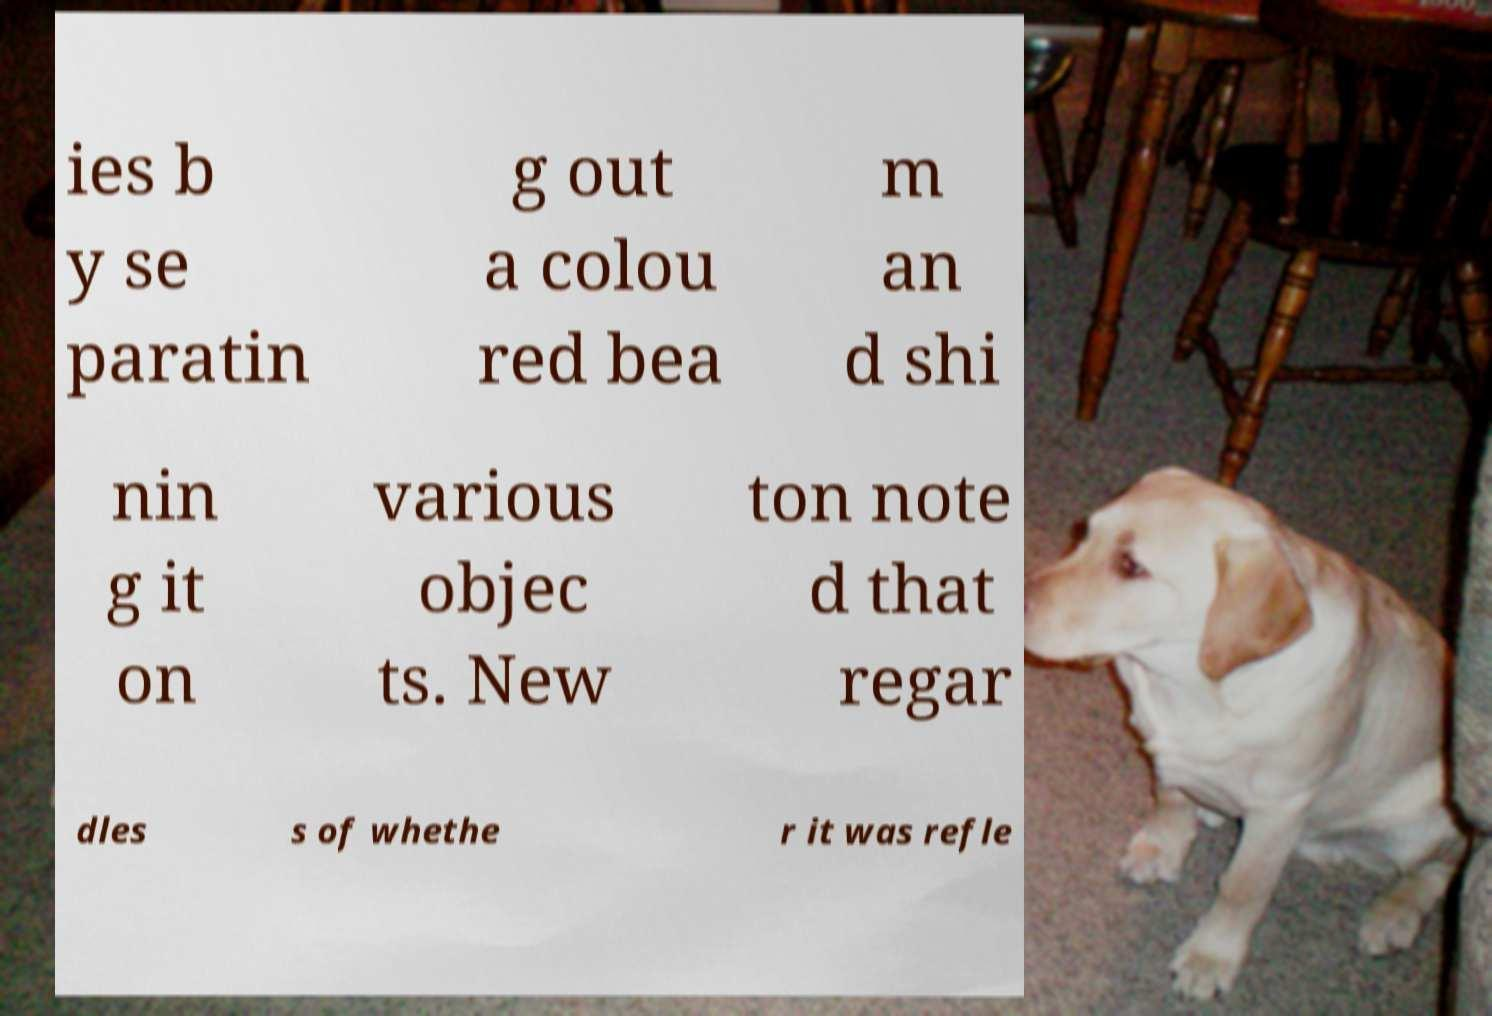Could you assist in decoding the text presented in this image and type it out clearly? ies b y se paratin g out a colou red bea m an d shi nin g it on various objec ts. New ton note d that regar dles s of whethe r it was refle 